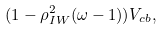Convert formula to latex. <formula><loc_0><loc_0><loc_500><loc_500>( 1 - \rho ^ { 2 } _ { I W } ( \omega - 1 ) ) V _ { c b } ,</formula> 